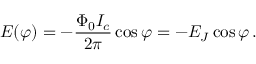<formula> <loc_0><loc_0><loc_500><loc_500>E ( \varphi ) = - { \frac { \Phi _ { 0 } I _ { c } } { 2 \pi } } \cos \varphi = - E _ { J } \cos \varphi \, .</formula> 